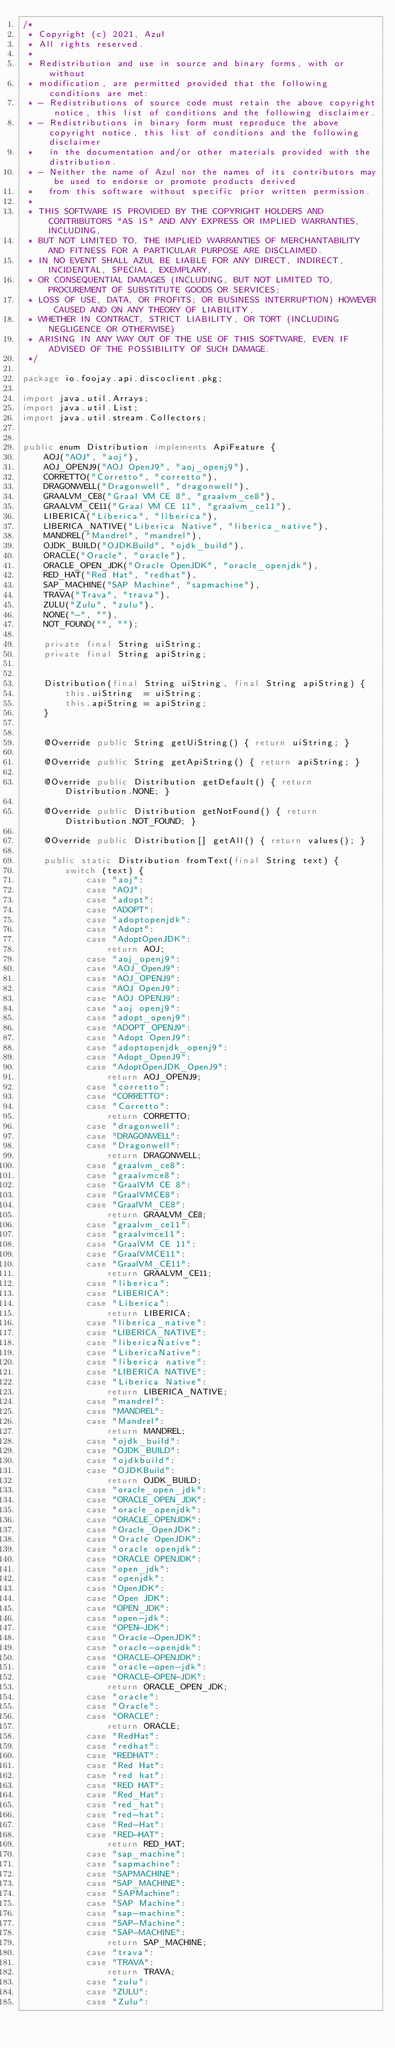<code> <loc_0><loc_0><loc_500><loc_500><_Java_>/*
 * Copyright (c) 2021, Azul
 * All rights reserved.
 *
 * Redistribution and use in source and binary forms, with or without
 * modification, are permitted provided that the following conditions are met:
 * - Redistributions of source code must retain the above copyright notice, this list of conditions and the following disclaimer.
 * - Redistributions in binary form must reproduce the above copyright notice, this list of conditions and the following disclaimer
 *   in the documentation and/or other materials provided with the distribution.
 * - Neither the name of Azul nor the names of its contributors may be used to endorse or promote products derived
 *   from this software without specific prior written permission.
 *
 * THIS SOFTWARE IS PROVIDED BY THE COPYRIGHT HOLDERS AND CONTRIBUTORS "AS IS" AND ANY EXPRESS OR IMPLIED WARRANTIES, INCLUDING,
 * BUT NOT LIMITED TO, THE IMPLIED WARRANTIES OF MERCHANTABILITY AND FITNESS FOR A PARTICULAR PURPOSE ARE DISCLAIMED.
 * IN NO EVENT SHALL AZUL BE LIABLE FOR ANY DIRECT, INDIRECT, INCIDENTAL, SPECIAL, EXEMPLARY,
 * OR CONSEQUENTIAL DAMAGES (INCLUDING, BUT NOT LIMITED TO, PROCUREMENT OF SUBSTITUTE GOODS OR SERVICES;
 * LOSS OF USE, DATA, OR PROFITS; OR BUSINESS INTERRUPTION) HOWEVER CAUSED AND ON ANY THEORY OF LIABILITY,
 * WHETHER IN CONTRACT, STRICT LIABILITY, OR TORT (INCLUDING NEGLIGENCE OR OTHERWISE)
 * ARISING IN ANY WAY OUT OF THE USE OF THIS SOFTWARE, EVEN IF ADVISED OF THE POSSIBILITY OF SUCH DAMAGE.
 */

package io.foojay.api.discoclient.pkg;

import java.util.Arrays;
import java.util.List;
import java.util.stream.Collectors;


public enum Distribution implements ApiFeature {
    AOJ("AOJ", "aoj"),
    AOJ_OPENJ9("AOJ OpenJ9", "aoj_openj9"),
    CORRETTO("Corretto", "corretto"),
    DRAGONWELL("Dragonwell", "dragonwell"),
    GRAALVM_CE8("Graal VM CE 8", "graalvm_ce8"),
    GRAALVM_CE11("Graal VM CE 11", "graalvm_ce11"),
    LIBERICA("Liberica", "liberica"),
    LIBERICA_NATIVE("Liberica Native", "liberica_native"),
    MANDREL("Mandrel", "mandrel"),
    OJDK_BUILD("OJDKBuild", "ojdk_build"),
    ORACLE("Oracle", "oracle"),
    ORACLE_OPEN_JDK("Oracle OpenJDK", "oracle_openjdk"),
    RED_HAT("Red Hat", "redhat"),
    SAP_MACHINE("SAP Machine", "sapmachine"),
    TRAVA("Trava", "trava"),
    ZULU("Zulu", "zulu"),
    NONE("-", ""),
    NOT_FOUND("", "");

    private final String uiString;
    private final String apiString;


    Distribution(final String uiString, final String apiString) {
        this.uiString  = uiString;
        this.apiString = apiString;
    }


    @Override public String getUiString() { return uiString; }

    @Override public String getApiString() { return apiString; }

    @Override public Distribution getDefault() { return Distribution.NONE; }

    @Override public Distribution getNotFound() { return Distribution.NOT_FOUND; }

    @Override public Distribution[] getAll() { return values(); }

    public static Distribution fromText(final String text) {
        switch (text) {
            case "aoj":
            case "AOJ":
            case "adopt":
            case "ADOPT":
            case "adoptopenjdk":
            case "Adopt":
            case "AdoptOpenJDK":
                return AOJ;
            case "aoj_openj9":
            case "AOJ_OpenJ9":
            case "AOJ_OPENJ9":
            case "AOJ OpenJ9":
            case "AOJ OPENJ9":
            case "aoj openj9":
            case "adopt_openj9":
            case "ADOPT_OPENJ9":
            case "Adopt OpenJ9":
            case "adoptopenjdk_openj9":
            case "Adopt_OpenJ9":
            case "AdoptOpenJDK_OpenJ9":
                return AOJ_OPENJ9;
            case "corretto":
            case "CORRETTO":
            case "Corretto":
                return CORRETTO;
            case "dragonwell":
            case "DRAGONWELL":
            case "Dragonwell":
                return DRAGONWELL;
            case "graalvm_ce8":
            case "graalvmce8":
            case "GraalVM CE 8":
            case "GraalVMCE8":
            case "GraalVM_CE8":
                return GRAALVM_CE8;
            case "graalvm_ce11":
            case "graalvmce11":
            case "GraalVM CE 11":
            case "GraalVMCE11":
            case "GraalVM_CE11":
                return GRAALVM_CE11;
            case "liberica":
            case "LIBERICA":
            case "Liberica":
                return LIBERICA;
            case "liberica_native":
            case "LIBERICA_NATIVE":
            case "libericaNative":
            case "LibericaNative":
            case "liberica native":
            case "LIBERICA NATIVE":
            case "Liberica Native":
                return LIBERICA_NATIVE;
            case "mandrel":
            case "MANDREL":
            case "Mandrel":
                return MANDREL;
            case "ojdk_build":
            case "OJDK_BUILD":
            case "ojdkbuild":
            case "OJDKBuild":
                return OJDK_BUILD;
            case "oracle_open_jdk":
            case "ORACLE_OPEN_JDK":
            case "oracle_openjdk":
            case "ORACLE_OPENJDK":
            case "Oracle_OpenJDK":
            case "Oracle OpenJDK":
            case "oracle openjdk":
            case "ORACLE OPENJDK":
            case "open_jdk":
            case "openjdk":
            case "OpenJDK":
            case "Open JDK":
            case "OPEN_JDK":
            case "open-jdk":
            case "OPEN-JDK":
            case "Oracle-OpenJDK":
            case "oracle-openjdk":
            case "ORACLE-OPENJDK":
            case "oracle-open-jdk":
            case "ORACLE-OPEN-JDK":
                return ORACLE_OPEN_JDK;
            case "oracle":
            case "Oracle":
            case "ORACLE":
                return ORACLE;
            case "RedHat":
            case "redhat":
            case "REDHAT":
            case "Red Hat":
            case "red hat":
            case "RED HAT":
            case "Red_Hat":
            case "red_hat":
            case "red-hat":
            case "Red-Hat":
            case "RED-HAT":
                return RED_HAT;
            case "sap_machine":
            case "sapmachine":
            case "SAPMACHINE":
            case "SAP_MACHINE":
            case "SAPMachine":
            case "SAP Machine":
            case "sap-machine":
            case "SAP-Machine":
            case "SAP-MACHINE":
                return SAP_MACHINE;
            case "trava":
            case "TRAVA":
                return TRAVA;
            case "zulu":
            case "ZULU":
            case "Zulu":</code> 